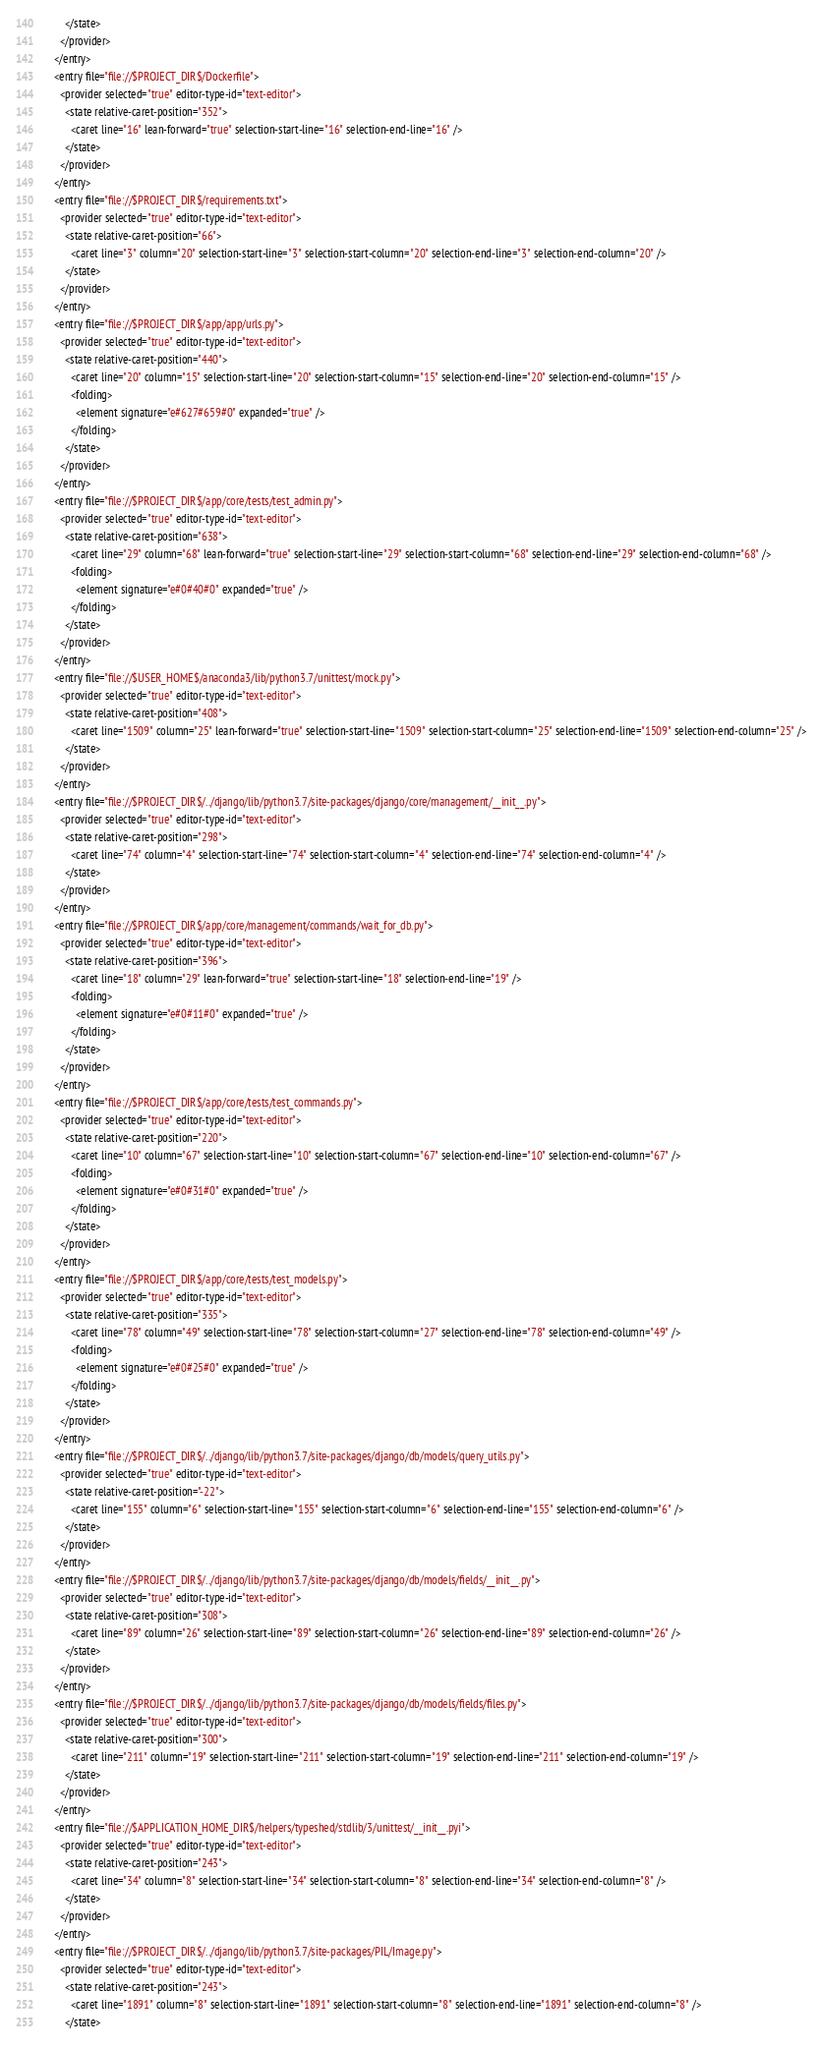Convert code to text. <code><loc_0><loc_0><loc_500><loc_500><_XML_>        </state>
      </provider>
    </entry>
    <entry file="file://$PROJECT_DIR$/Dockerfile">
      <provider selected="true" editor-type-id="text-editor">
        <state relative-caret-position="352">
          <caret line="16" lean-forward="true" selection-start-line="16" selection-end-line="16" />
        </state>
      </provider>
    </entry>
    <entry file="file://$PROJECT_DIR$/requirements.txt">
      <provider selected="true" editor-type-id="text-editor">
        <state relative-caret-position="66">
          <caret line="3" column="20" selection-start-line="3" selection-start-column="20" selection-end-line="3" selection-end-column="20" />
        </state>
      </provider>
    </entry>
    <entry file="file://$PROJECT_DIR$/app/app/urls.py">
      <provider selected="true" editor-type-id="text-editor">
        <state relative-caret-position="440">
          <caret line="20" column="15" selection-start-line="20" selection-start-column="15" selection-end-line="20" selection-end-column="15" />
          <folding>
            <element signature="e#627#659#0" expanded="true" />
          </folding>
        </state>
      </provider>
    </entry>
    <entry file="file://$PROJECT_DIR$/app/core/tests/test_admin.py">
      <provider selected="true" editor-type-id="text-editor">
        <state relative-caret-position="638">
          <caret line="29" column="68" lean-forward="true" selection-start-line="29" selection-start-column="68" selection-end-line="29" selection-end-column="68" />
          <folding>
            <element signature="e#0#40#0" expanded="true" />
          </folding>
        </state>
      </provider>
    </entry>
    <entry file="file://$USER_HOME$/anaconda3/lib/python3.7/unittest/mock.py">
      <provider selected="true" editor-type-id="text-editor">
        <state relative-caret-position="408">
          <caret line="1509" column="25" lean-forward="true" selection-start-line="1509" selection-start-column="25" selection-end-line="1509" selection-end-column="25" />
        </state>
      </provider>
    </entry>
    <entry file="file://$PROJECT_DIR$/../django/lib/python3.7/site-packages/django/core/management/__init__.py">
      <provider selected="true" editor-type-id="text-editor">
        <state relative-caret-position="298">
          <caret line="74" column="4" selection-start-line="74" selection-start-column="4" selection-end-line="74" selection-end-column="4" />
        </state>
      </provider>
    </entry>
    <entry file="file://$PROJECT_DIR$/app/core/management/commands/wait_for_db.py">
      <provider selected="true" editor-type-id="text-editor">
        <state relative-caret-position="396">
          <caret line="18" column="29" lean-forward="true" selection-start-line="18" selection-end-line="19" />
          <folding>
            <element signature="e#0#11#0" expanded="true" />
          </folding>
        </state>
      </provider>
    </entry>
    <entry file="file://$PROJECT_DIR$/app/core/tests/test_commands.py">
      <provider selected="true" editor-type-id="text-editor">
        <state relative-caret-position="220">
          <caret line="10" column="67" selection-start-line="10" selection-start-column="67" selection-end-line="10" selection-end-column="67" />
          <folding>
            <element signature="e#0#31#0" expanded="true" />
          </folding>
        </state>
      </provider>
    </entry>
    <entry file="file://$PROJECT_DIR$/app/core/tests/test_models.py">
      <provider selected="true" editor-type-id="text-editor">
        <state relative-caret-position="335">
          <caret line="78" column="49" selection-start-line="78" selection-start-column="27" selection-end-line="78" selection-end-column="49" />
          <folding>
            <element signature="e#0#25#0" expanded="true" />
          </folding>
        </state>
      </provider>
    </entry>
    <entry file="file://$PROJECT_DIR$/../django/lib/python3.7/site-packages/django/db/models/query_utils.py">
      <provider selected="true" editor-type-id="text-editor">
        <state relative-caret-position="-22">
          <caret line="155" column="6" selection-start-line="155" selection-start-column="6" selection-end-line="155" selection-end-column="6" />
        </state>
      </provider>
    </entry>
    <entry file="file://$PROJECT_DIR$/../django/lib/python3.7/site-packages/django/db/models/fields/__init__.py">
      <provider selected="true" editor-type-id="text-editor">
        <state relative-caret-position="308">
          <caret line="89" column="26" selection-start-line="89" selection-start-column="26" selection-end-line="89" selection-end-column="26" />
        </state>
      </provider>
    </entry>
    <entry file="file://$PROJECT_DIR$/../django/lib/python3.7/site-packages/django/db/models/fields/files.py">
      <provider selected="true" editor-type-id="text-editor">
        <state relative-caret-position="300">
          <caret line="211" column="19" selection-start-line="211" selection-start-column="19" selection-end-line="211" selection-end-column="19" />
        </state>
      </provider>
    </entry>
    <entry file="file://$APPLICATION_HOME_DIR$/helpers/typeshed/stdlib/3/unittest/__init__.pyi">
      <provider selected="true" editor-type-id="text-editor">
        <state relative-caret-position="243">
          <caret line="34" column="8" selection-start-line="34" selection-start-column="8" selection-end-line="34" selection-end-column="8" />
        </state>
      </provider>
    </entry>
    <entry file="file://$PROJECT_DIR$/../django/lib/python3.7/site-packages/PIL/Image.py">
      <provider selected="true" editor-type-id="text-editor">
        <state relative-caret-position="243">
          <caret line="1891" column="8" selection-start-line="1891" selection-start-column="8" selection-end-line="1891" selection-end-column="8" />
        </state></code> 